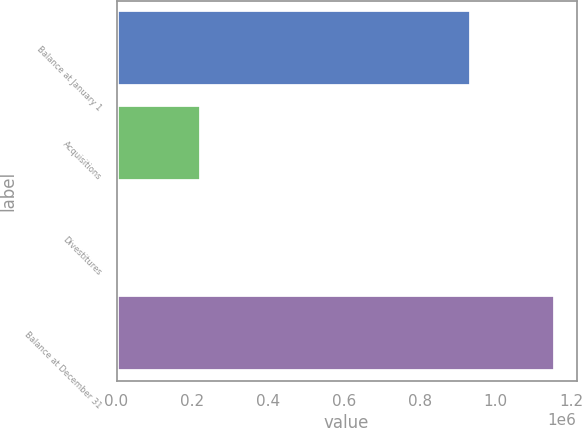Convert chart to OTSL. <chart><loc_0><loc_0><loc_500><loc_500><bar_chart><fcel>Balance at January 1<fcel>Acquisitions<fcel>Divestitures<fcel>Balance at December 31<nl><fcel>934188<fcel>222424<fcel>386<fcel>1.15623e+06<nl></chart> 